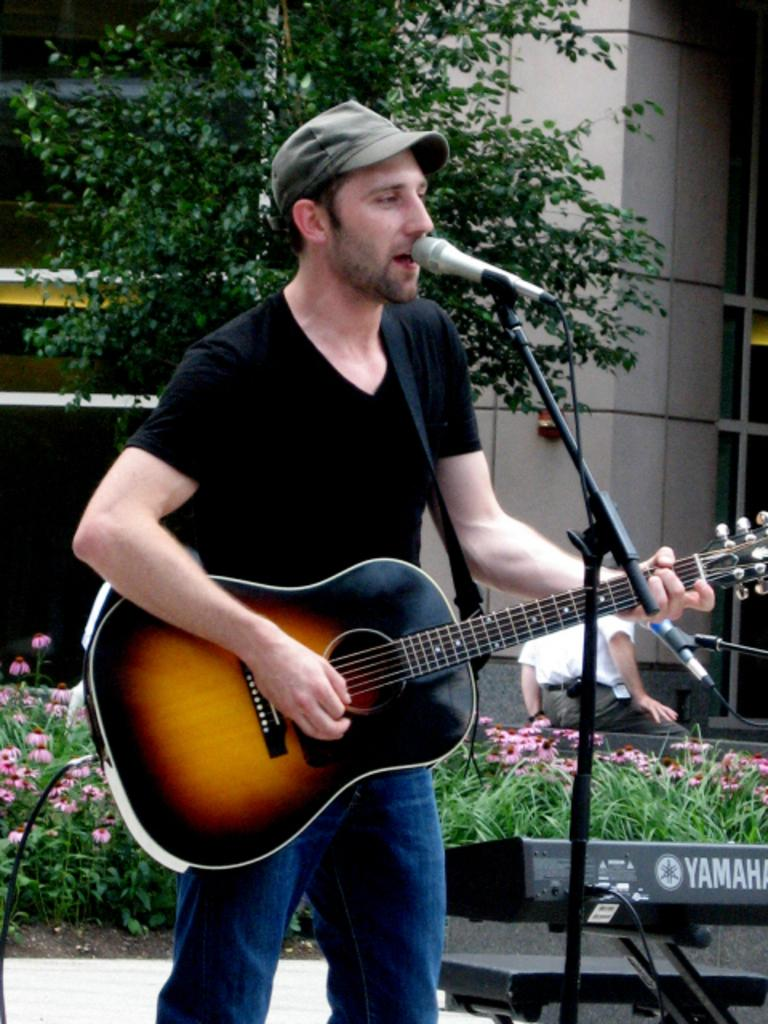What type of structure is visible in the image? There is a building in the image. What natural element is present in the image? There is a tree in the image. What type of vegetation can be seen in the image? There are plants in the image. What is the man in the image doing? The man is holding a guitar in the image. What object is in front of the man? There is a microphone in front of the man. How many sisters does the tree in the image have? There are no sisters mentioned or depicted in the image, as it features a building, a tree, plants, a man holding a guitar, and a microphone. 